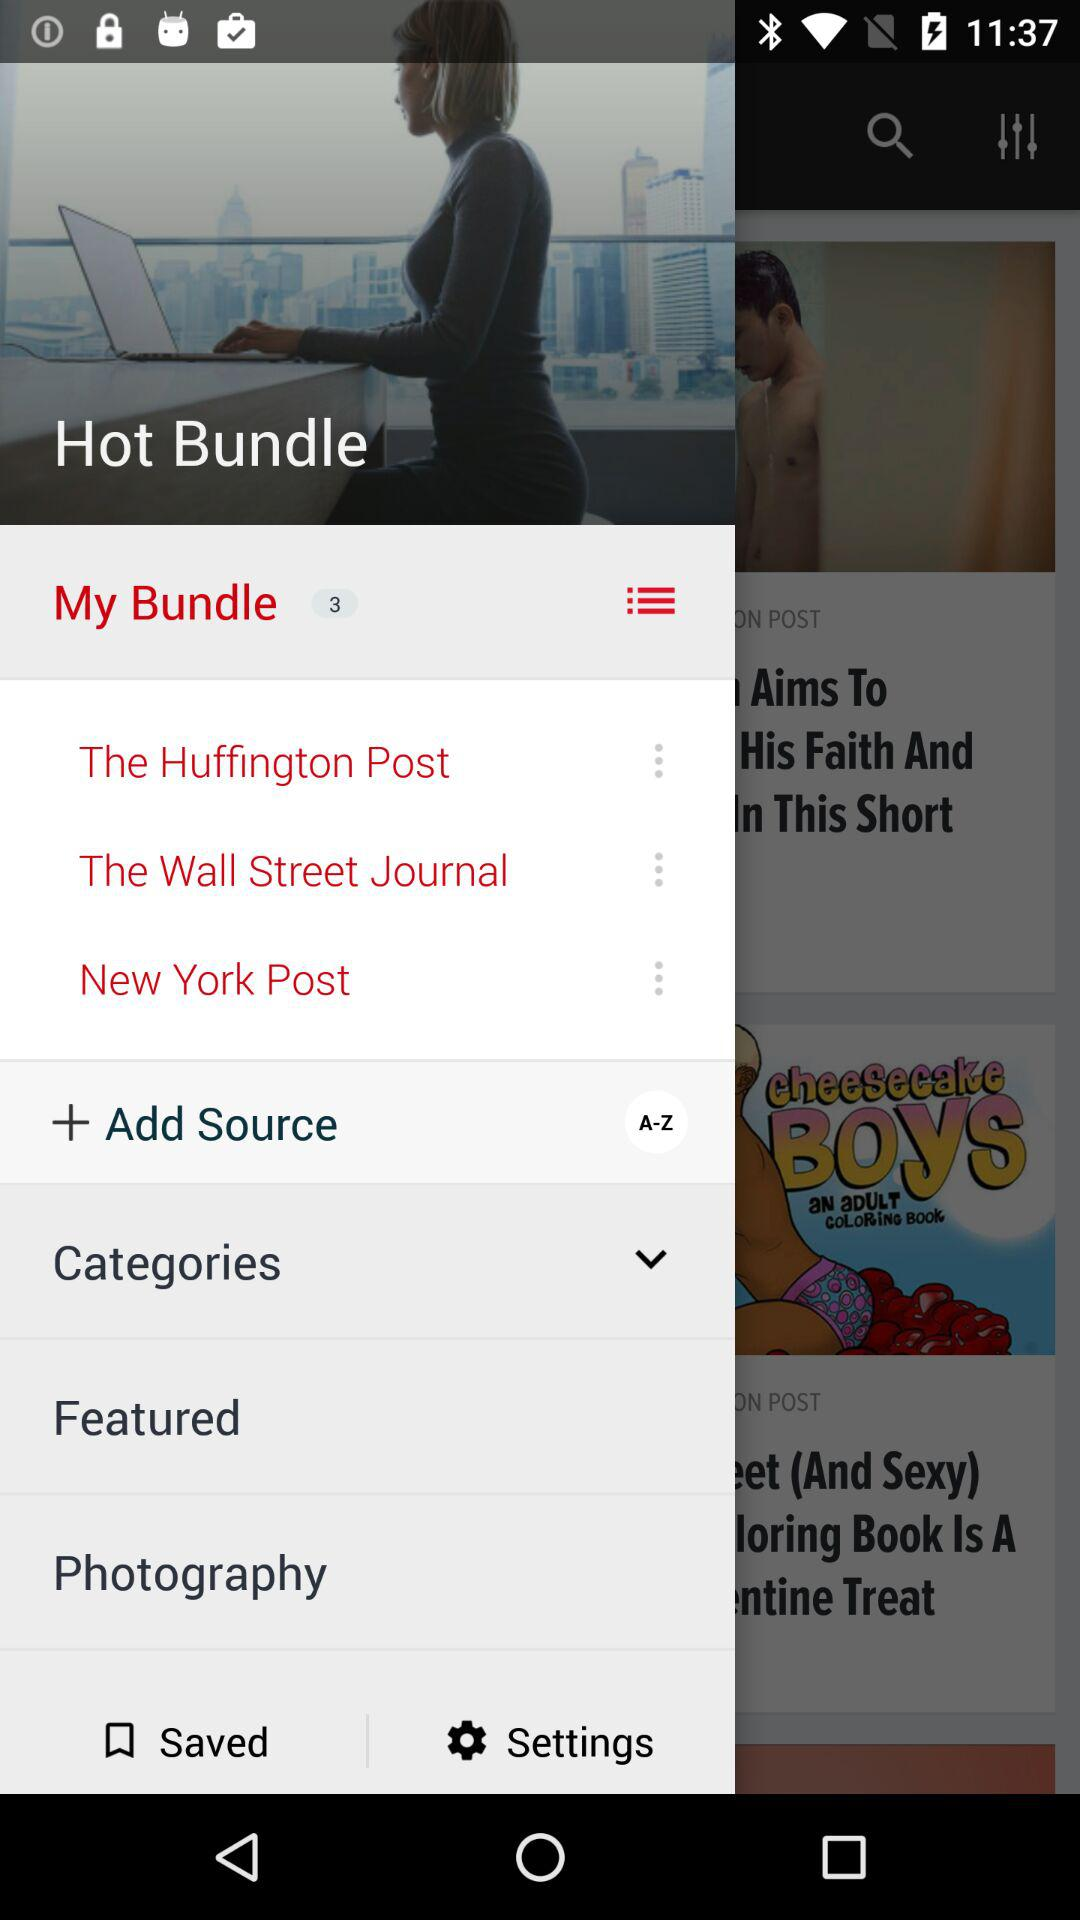What is the name of the application?
When the provided information is insufficient, respond with <no answer>. <no answer> 